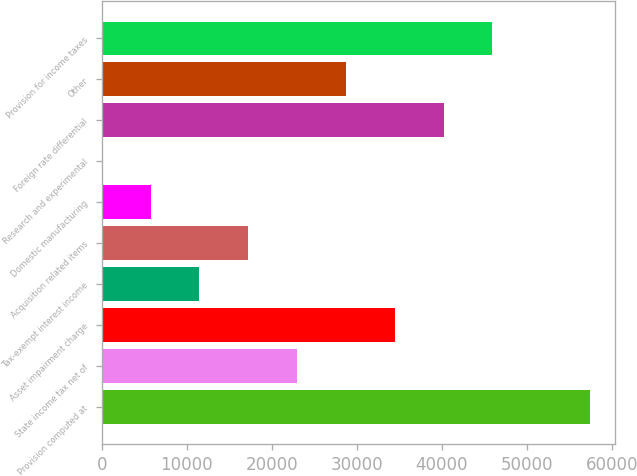Convert chart. <chart><loc_0><loc_0><loc_500><loc_500><bar_chart><fcel>Provision computed at<fcel>State income tax net of<fcel>Asset impairment charge<fcel>Tax-exempt interest income<fcel>Acquisition related items<fcel>Domestic manufacturing<fcel>Research and experimental<fcel>Foreign rate differential<fcel>Other<fcel>Provision for income taxes<nl><fcel>57461<fcel>22985.8<fcel>34477.5<fcel>11494.1<fcel>17240<fcel>5748.24<fcel>2.38<fcel>40223.4<fcel>28731.7<fcel>45969.3<nl></chart> 